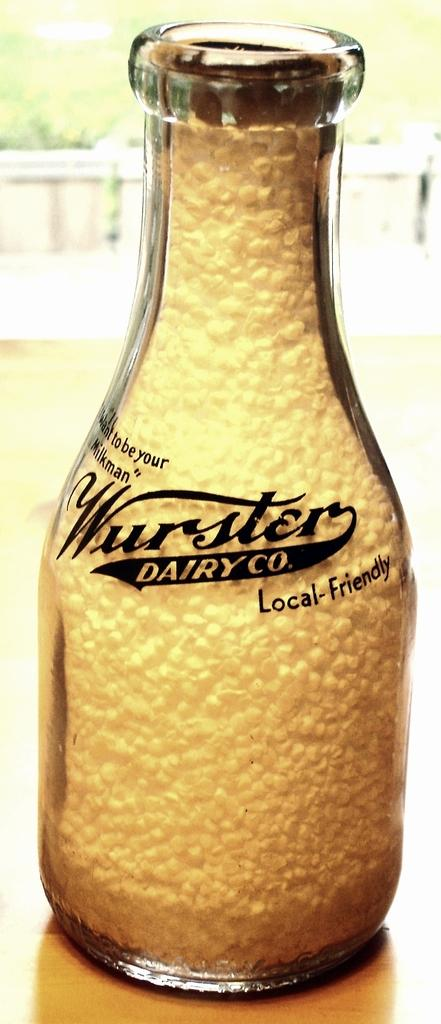<image>
Relay a brief, clear account of the picture shown. A bottle labeled Wurster Dairy Co has white beeds in it. 